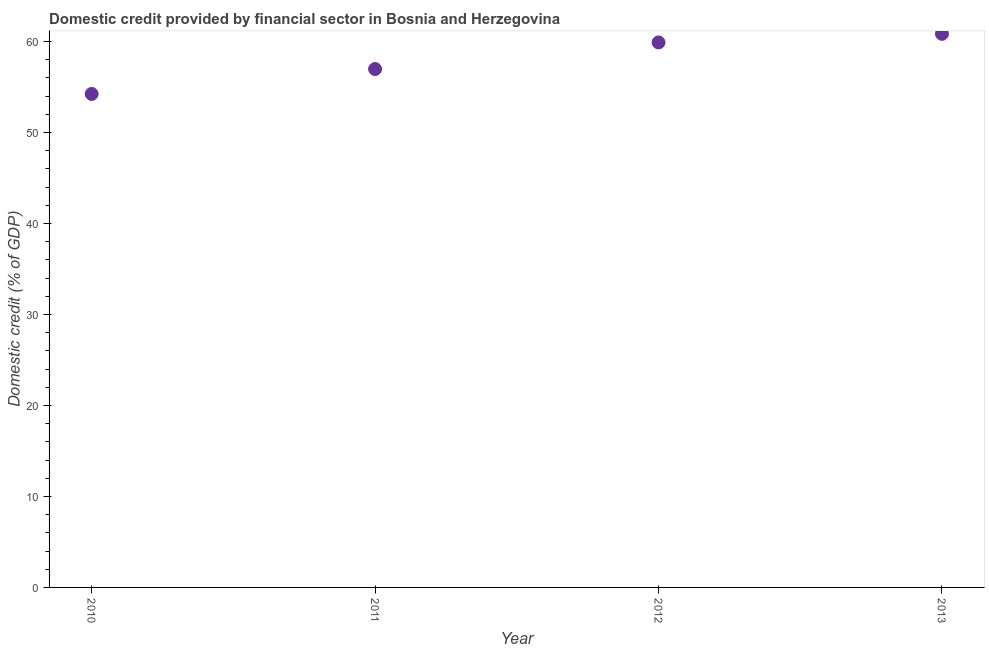What is the domestic credit provided by financial sector in 2011?
Provide a succinct answer. 56.97. Across all years, what is the maximum domestic credit provided by financial sector?
Give a very brief answer. 60.84. Across all years, what is the minimum domestic credit provided by financial sector?
Ensure brevity in your answer.  54.24. What is the sum of the domestic credit provided by financial sector?
Offer a very short reply. 231.95. What is the difference between the domestic credit provided by financial sector in 2010 and 2011?
Ensure brevity in your answer.  -2.74. What is the average domestic credit provided by financial sector per year?
Offer a terse response. 57.99. What is the median domestic credit provided by financial sector?
Your answer should be very brief. 58.44. What is the ratio of the domestic credit provided by financial sector in 2010 to that in 2011?
Offer a very short reply. 0.95. Is the domestic credit provided by financial sector in 2010 less than that in 2012?
Your answer should be very brief. Yes. Is the difference between the domestic credit provided by financial sector in 2011 and 2012 greater than the difference between any two years?
Your answer should be very brief. No. What is the difference between the highest and the second highest domestic credit provided by financial sector?
Provide a short and direct response. 0.94. Is the sum of the domestic credit provided by financial sector in 2011 and 2013 greater than the maximum domestic credit provided by financial sector across all years?
Provide a short and direct response. Yes. What is the difference between the highest and the lowest domestic credit provided by financial sector?
Provide a succinct answer. 6.61. In how many years, is the domestic credit provided by financial sector greater than the average domestic credit provided by financial sector taken over all years?
Provide a succinct answer. 2. What is the difference between two consecutive major ticks on the Y-axis?
Keep it short and to the point. 10. Does the graph contain grids?
Ensure brevity in your answer.  No. What is the title of the graph?
Give a very brief answer. Domestic credit provided by financial sector in Bosnia and Herzegovina. What is the label or title of the X-axis?
Your answer should be compact. Year. What is the label or title of the Y-axis?
Keep it short and to the point. Domestic credit (% of GDP). What is the Domestic credit (% of GDP) in 2010?
Provide a short and direct response. 54.24. What is the Domestic credit (% of GDP) in 2011?
Provide a succinct answer. 56.97. What is the Domestic credit (% of GDP) in 2012?
Provide a succinct answer. 59.9. What is the Domestic credit (% of GDP) in 2013?
Keep it short and to the point. 60.84. What is the difference between the Domestic credit (% of GDP) in 2010 and 2011?
Provide a succinct answer. -2.74. What is the difference between the Domestic credit (% of GDP) in 2010 and 2012?
Your answer should be compact. -5.66. What is the difference between the Domestic credit (% of GDP) in 2010 and 2013?
Make the answer very short. -6.61. What is the difference between the Domestic credit (% of GDP) in 2011 and 2012?
Your answer should be very brief. -2.93. What is the difference between the Domestic credit (% of GDP) in 2011 and 2013?
Make the answer very short. -3.87. What is the difference between the Domestic credit (% of GDP) in 2012 and 2013?
Provide a short and direct response. -0.94. What is the ratio of the Domestic credit (% of GDP) in 2010 to that in 2012?
Offer a terse response. 0.91. What is the ratio of the Domestic credit (% of GDP) in 2010 to that in 2013?
Offer a terse response. 0.89. What is the ratio of the Domestic credit (% of GDP) in 2011 to that in 2012?
Your answer should be very brief. 0.95. What is the ratio of the Domestic credit (% of GDP) in 2011 to that in 2013?
Your answer should be compact. 0.94. What is the ratio of the Domestic credit (% of GDP) in 2012 to that in 2013?
Keep it short and to the point. 0.98. 